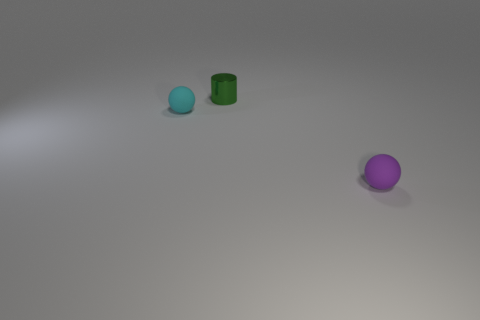Add 1 yellow metallic cylinders. How many objects exist? 4 Subtract all balls. How many objects are left? 1 Subtract all large brown matte balls. Subtract all small metal objects. How many objects are left? 2 Add 2 purple rubber spheres. How many purple rubber spheres are left? 3 Add 1 small green cylinders. How many small green cylinders exist? 2 Subtract 0 gray cylinders. How many objects are left? 3 